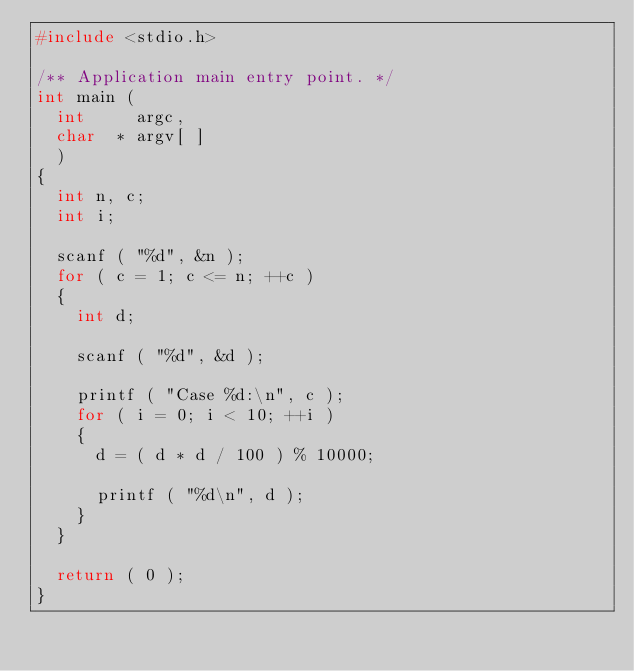Convert code to text. <code><loc_0><loc_0><loc_500><loc_500><_C_>#include <stdio.h>

/** Application main entry point. */
int main (
  int     argc,
  char  * argv[ ]
  )
{
  int n, c;
  int i;

  scanf ( "%d", &n );
  for ( c = 1; c <= n; ++c )
  {
    int d;

    scanf ( "%d", &d );

    printf ( "Case %d:\n", c );
    for ( i = 0; i < 10; ++i )
    {
      d = ( d * d / 100 ) % 10000;

      printf ( "%d\n", d );
    }
  }

  return ( 0 );
}</code> 